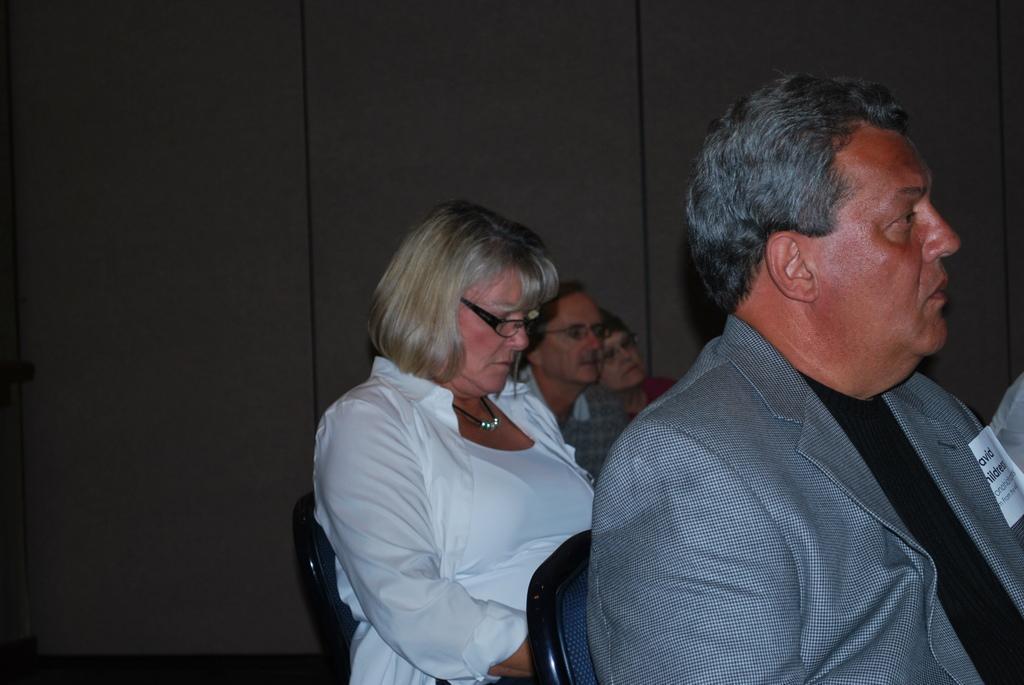Please provide a concise description of this image. In this picture to the right side there is a man with grey color jacket and black t-shirt. He is sitting. Behind him there is a lady with white dress is sitting. Beside there are two people sitting. In the background there is a grey color. 